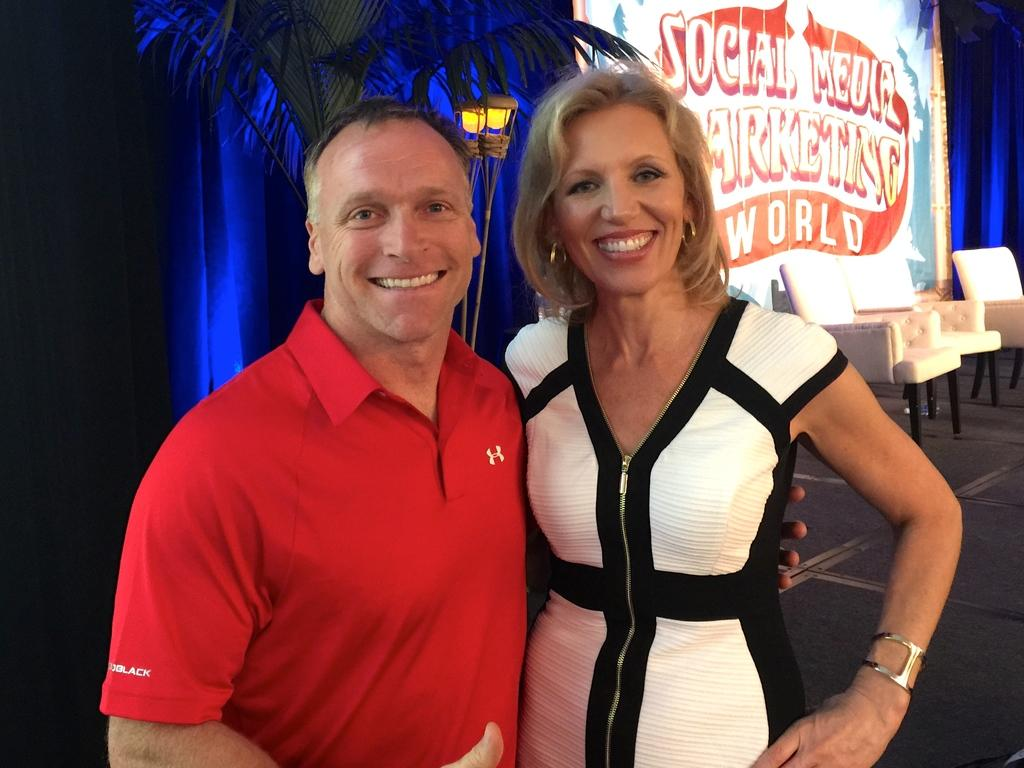<image>
Provide a brief description of the given image. A couple in front of a sign that says Social Media Marketing. 